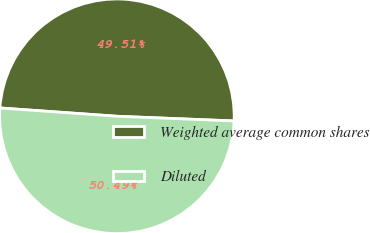<chart> <loc_0><loc_0><loc_500><loc_500><pie_chart><fcel>Weighted average common shares<fcel>Diluted<nl><fcel>49.51%<fcel>50.49%<nl></chart> 